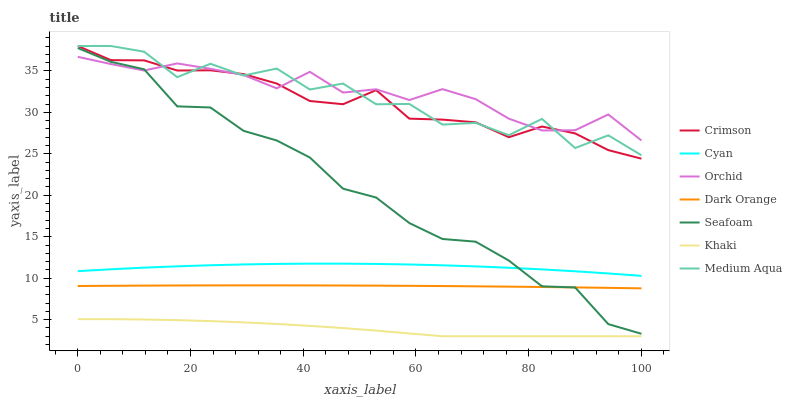Does Khaki have the minimum area under the curve?
Answer yes or no. Yes. Does Orchid have the maximum area under the curve?
Answer yes or no. Yes. Does Seafoam have the minimum area under the curve?
Answer yes or no. No. Does Seafoam have the maximum area under the curve?
Answer yes or no. No. Is Dark Orange the smoothest?
Answer yes or no. Yes. Is Medium Aqua the roughest?
Answer yes or no. Yes. Is Khaki the smoothest?
Answer yes or no. No. Is Khaki the roughest?
Answer yes or no. No. Does Khaki have the lowest value?
Answer yes or no. Yes. Does Seafoam have the lowest value?
Answer yes or no. No. Does Crimson have the highest value?
Answer yes or no. Yes. Does Seafoam have the highest value?
Answer yes or no. No. Is Cyan less than Orchid?
Answer yes or no. Yes. Is Medium Aqua greater than Dark Orange?
Answer yes or no. Yes. Does Crimson intersect Medium Aqua?
Answer yes or no. Yes. Is Crimson less than Medium Aqua?
Answer yes or no. No. Is Crimson greater than Medium Aqua?
Answer yes or no. No. Does Cyan intersect Orchid?
Answer yes or no. No. 